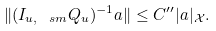<formula> <loc_0><loc_0><loc_500><loc_500>\| ( I _ { u , \ s m } Q _ { u } ) ^ { - 1 } a \| \leq C ^ { \prime \prime } | a | _ { \mathcal { X } } .</formula> 